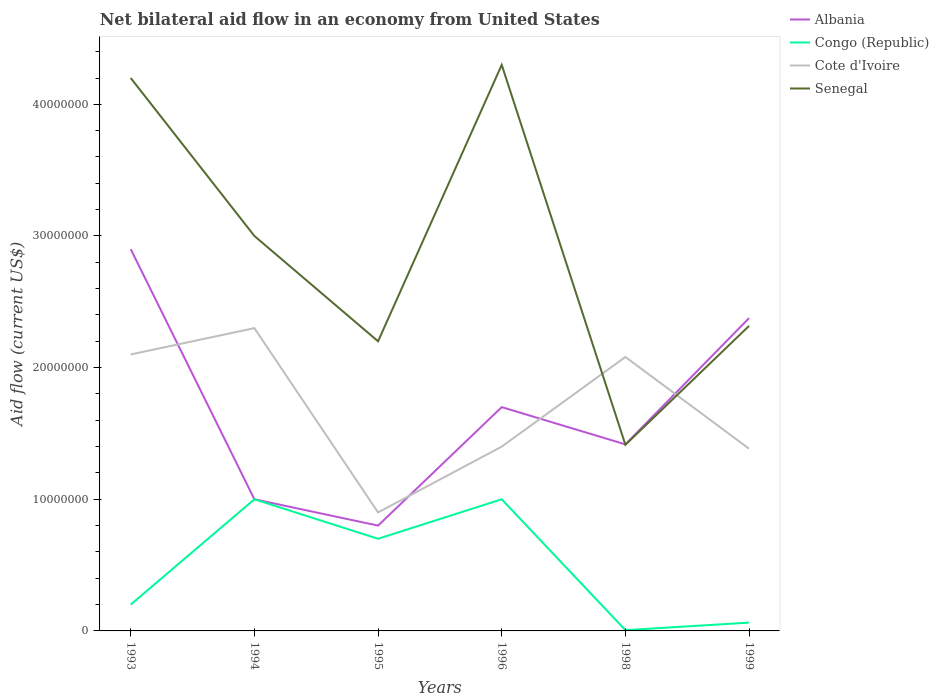How many different coloured lines are there?
Ensure brevity in your answer.  4. Does the line corresponding to Cote d'Ivoire intersect with the line corresponding to Senegal?
Keep it short and to the point. Yes. Is the number of lines equal to the number of legend labels?
Ensure brevity in your answer.  Yes. What is the total net bilateral aid flow in Cote d'Ivoire in the graph?
Offer a terse response. 1.90e+05. What is the difference between the highest and the second highest net bilateral aid flow in Congo (Republic)?
Your answer should be compact. 9.94e+06. What is the difference between the highest and the lowest net bilateral aid flow in Congo (Republic)?
Keep it short and to the point. 3. Is the net bilateral aid flow in Congo (Republic) strictly greater than the net bilateral aid flow in Cote d'Ivoire over the years?
Ensure brevity in your answer.  Yes. How many lines are there?
Your answer should be compact. 4. What is the difference between two consecutive major ticks on the Y-axis?
Offer a very short reply. 1.00e+07. How many legend labels are there?
Provide a short and direct response. 4. How are the legend labels stacked?
Offer a terse response. Vertical. What is the title of the graph?
Give a very brief answer. Net bilateral aid flow in an economy from United States. Does "Djibouti" appear as one of the legend labels in the graph?
Make the answer very short. No. What is the label or title of the Y-axis?
Give a very brief answer. Aid flow (current US$). What is the Aid flow (current US$) of Albania in 1993?
Provide a short and direct response. 2.90e+07. What is the Aid flow (current US$) of Cote d'Ivoire in 1993?
Ensure brevity in your answer.  2.10e+07. What is the Aid flow (current US$) of Senegal in 1993?
Give a very brief answer. 4.20e+07. What is the Aid flow (current US$) in Cote d'Ivoire in 1994?
Offer a terse response. 2.30e+07. What is the Aid flow (current US$) in Senegal in 1994?
Make the answer very short. 3.00e+07. What is the Aid flow (current US$) of Congo (Republic) in 1995?
Offer a very short reply. 7.00e+06. What is the Aid flow (current US$) of Cote d'Ivoire in 1995?
Keep it short and to the point. 9.00e+06. What is the Aid flow (current US$) in Senegal in 1995?
Offer a terse response. 2.20e+07. What is the Aid flow (current US$) of Albania in 1996?
Your response must be concise. 1.70e+07. What is the Aid flow (current US$) in Cote d'Ivoire in 1996?
Provide a succinct answer. 1.40e+07. What is the Aid flow (current US$) in Senegal in 1996?
Ensure brevity in your answer.  4.30e+07. What is the Aid flow (current US$) in Albania in 1998?
Your answer should be very brief. 1.42e+07. What is the Aid flow (current US$) in Cote d'Ivoire in 1998?
Your answer should be very brief. 2.08e+07. What is the Aid flow (current US$) of Senegal in 1998?
Give a very brief answer. 1.41e+07. What is the Aid flow (current US$) in Albania in 1999?
Give a very brief answer. 2.38e+07. What is the Aid flow (current US$) of Congo (Republic) in 1999?
Your answer should be compact. 6.30e+05. What is the Aid flow (current US$) of Cote d'Ivoire in 1999?
Offer a very short reply. 1.38e+07. What is the Aid flow (current US$) of Senegal in 1999?
Your response must be concise. 2.32e+07. Across all years, what is the maximum Aid flow (current US$) of Albania?
Provide a short and direct response. 2.90e+07. Across all years, what is the maximum Aid flow (current US$) of Cote d'Ivoire?
Your response must be concise. 2.30e+07. Across all years, what is the maximum Aid flow (current US$) of Senegal?
Give a very brief answer. 4.30e+07. Across all years, what is the minimum Aid flow (current US$) in Cote d'Ivoire?
Make the answer very short. 9.00e+06. Across all years, what is the minimum Aid flow (current US$) in Senegal?
Your answer should be compact. 1.41e+07. What is the total Aid flow (current US$) of Albania in the graph?
Your response must be concise. 1.02e+08. What is the total Aid flow (current US$) in Congo (Republic) in the graph?
Ensure brevity in your answer.  2.97e+07. What is the total Aid flow (current US$) of Cote d'Ivoire in the graph?
Ensure brevity in your answer.  1.02e+08. What is the total Aid flow (current US$) in Senegal in the graph?
Ensure brevity in your answer.  1.74e+08. What is the difference between the Aid flow (current US$) of Albania in 1993 and that in 1994?
Provide a succinct answer. 1.90e+07. What is the difference between the Aid flow (current US$) in Congo (Republic) in 1993 and that in 1994?
Give a very brief answer. -8.00e+06. What is the difference between the Aid flow (current US$) of Senegal in 1993 and that in 1994?
Offer a very short reply. 1.20e+07. What is the difference between the Aid flow (current US$) of Albania in 1993 and that in 1995?
Your response must be concise. 2.10e+07. What is the difference between the Aid flow (current US$) of Congo (Republic) in 1993 and that in 1995?
Make the answer very short. -5.00e+06. What is the difference between the Aid flow (current US$) in Senegal in 1993 and that in 1995?
Offer a very short reply. 2.00e+07. What is the difference between the Aid flow (current US$) in Congo (Republic) in 1993 and that in 1996?
Ensure brevity in your answer.  -8.00e+06. What is the difference between the Aid flow (current US$) of Albania in 1993 and that in 1998?
Make the answer very short. 1.48e+07. What is the difference between the Aid flow (current US$) in Congo (Republic) in 1993 and that in 1998?
Give a very brief answer. 1.94e+06. What is the difference between the Aid flow (current US$) in Senegal in 1993 and that in 1998?
Your answer should be compact. 2.79e+07. What is the difference between the Aid flow (current US$) of Albania in 1993 and that in 1999?
Provide a succinct answer. 5.24e+06. What is the difference between the Aid flow (current US$) in Congo (Republic) in 1993 and that in 1999?
Provide a succinct answer. 1.37e+06. What is the difference between the Aid flow (current US$) of Cote d'Ivoire in 1993 and that in 1999?
Give a very brief answer. 7.16e+06. What is the difference between the Aid flow (current US$) of Senegal in 1993 and that in 1999?
Ensure brevity in your answer.  1.88e+07. What is the difference between the Aid flow (current US$) of Albania in 1994 and that in 1995?
Provide a short and direct response. 2.00e+06. What is the difference between the Aid flow (current US$) in Congo (Republic) in 1994 and that in 1995?
Give a very brief answer. 3.00e+06. What is the difference between the Aid flow (current US$) of Cote d'Ivoire in 1994 and that in 1995?
Make the answer very short. 1.40e+07. What is the difference between the Aid flow (current US$) in Albania in 1994 and that in 1996?
Keep it short and to the point. -7.00e+06. What is the difference between the Aid flow (current US$) of Congo (Republic) in 1994 and that in 1996?
Your answer should be compact. 0. What is the difference between the Aid flow (current US$) of Cote d'Ivoire in 1994 and that in 1996?
Offer a terse response. 9.00e+06. What is the difference between the Aid flow (current US$) of Senegal in 1994 and that in 1996?
Provide a short and direct response. -1.30e+07. What is the difference between the Aid flow (current US$) of Albania in 1994 and that in 1998?
Offer a very short reply. -4.17e+06. What is the difference between the Aid flow (current US$) of Congo (Republic) in 1994 and that in 1998?
Your answer should be very brief. 9.94e+06. What is the difference between the Aid flow (current US$) of Cote d'Ivoire in 1994 and that in 1998?
Your answer should be very brief. 2.19e+06. What is the difference between the Aid flow (current US$) in Senegal in 1994 and that in 1998?
Your answer should be very brief. 1.59e+07. What is the difference between the Aid flow (current US$) in Albania in 1994 and that in 1999?
Ensure brevity in your answer.  -1.38e+07. What is the difference between the Aid flow (current US$) in Congo (Republic) in 1994 and that in 1999?
Your answer should be compact. 9.37e+06. What is the difference between the Aid flow (current US$) of Cote d'Ivoire in 1994 and that in 1999?
Give a very brief answer. 9.16e+06. What is the difference between the Aid flow (current US$) in Senegal in 1994 and that in 1999?
Ensure brevity in your answer.  6.83e+06. What is the difference between the Aid flow (current US$) of Albania in 1995 and that in 1996?
Your answer should be compact. -9.00e+06. What is the difference between the Aid flow (current US$) of Cote d'Ivoire in 1995 and that in 1996?
Your answer should be very brief. -5.00e+06. What is the difference between the Aid flow (current US$) in Senegal in 1995 and that in 1996?
Keep it short and to the point. -2.10e+07. What is the difference between the Aid flow (current US$) in Albania in 1995 and that in 1998?
Provide a succinct answer. -6.17e+06. What is the difference between the Aid flow (current US$) in Congo (Republic) in 1995 and that in 1998?
Your answer should be compact. 6.94e+06. What is the difference between the Aid flow (current US$) of Cote d'Ivoire in 1995 and that in 1998?
Ensure brevity in your answer.  -1.18e+07. What is the difference between the Aid flow (current US$) in Senegal in 1995 and that in 1998?
Your response must be concise. 7.86e+06. What is the difference between the Aid flow (current US$) of Albania in 1995 and that in 1999?
Offer a terse response. -1.58e+07. What is the difference between the Aid flow (current US$) in Congo (Republic) in 1995 and that in 1999?
Your response must be concise. 6.37e+06. What is the difference between the Aid flow (current US$) of Cote d'Ivoire in 1995 and that in 1999?
Provide a succinct answer. -4.84e+06. What is the difference between the Aid flow (current US$) of Senegal in 1995 and that in 1999?
Offer a very short reply. -1.17e+06. What is the difference between the Aid flow (current US$) in Albania in 1996 and that in 1998?
Keep it short and to the point. 2.83e+06. What is the difference between the Aid flow (current US$) in Congo (Republic) in 1996 and that in 1998?
Offer a terse response. 9.94e+06. What is the difference between the Aid flow (current US$) in Cote d'Ivoire in 1996 and that in 1998?
Offer a terse response. -6.81e+06. What is the difference between the Aid flow (current US$) in Senegal in 1996 and that in 1998?
Make the answer very short. 2.89e+07. What is the difference between the Aid flow (current US$) of Albania in 1996 and that in 1999?
Ensure brevity in your answer.  -6.76e+06. What is the difference between the Aid flow (current US$) of Congo (Republic) in 1996 and that in 1999?
Make the answer very short. 9.37e+06. What is the difference between the Aid flow (current US$) of Senegal in 1996 and that in 1999?
Provide a succinct answer. 1.98e+07. What is the difference between the Aid flow (current US$) of Albania in 1998 and that in 1999?
Your answer should be compact. -9.59e+06. What is the difference between the Aid flow (current US$) in Congo (Republic) in 1998 and that in 1999?
Your answer should be very brief. -5.70e+05. What is the difference between the Aid flow (current US$) in Cote d'Ivoire in 1998 and that in 1999?
Give a very brief answer. 6.97e+06. What is the difference between the Aid flow (current US$) of Senegal in 1998 and that in 1999?
Your response must be concise. -9.03e+06. What is the difference between the Aid flow (current US$) in Albania in 1993 and the Aid flow (current US$) in Congo (Republic) in 1994?
Your response must be concise. 1.90e+07. What is the difference between the Aid flow (current US$) in Congo (Republic) in 1993 and the Aid flow (current US$) in Cote d'Ivoire in 1994?
Provide a succinct answer. -2.10e+07. What is the difference between the Aid flow (current US$) in Congo (Republic) in 1993 and the Aid flow (current US$) in Senegal in 1994?
Your answer should be very brief. -2.80e+07. What is the difference between the Aid flow (current US$) in Cote d'Ivoire in 1993 and the Aid flow (current US$) in Senegal in 1994?
Keep it short and to the point. -9.00e+06. What is the difference between the Aid flow (current US$) of Albania in 1993 and the Aid flow (current US$) of Congo (Republic) in 1995?
Provide a short and direct response. 2.20e+07. What is the difference between the Aid flow (current US$) in Albania in 1993 and the Aid flow (current US$) in Cote d'Ivoire in 1995?
Offer a terse response. 2.00e+07. What is the difference between the Aid flow (current US$) of Albania in 1993 and the Aid flow (current US$) of Senegal in 1995?
Give a very brief answer. 7.00e+06. What is the difference between the Aid flow (current US$) in Congo (Republic) in 1993 and the Aid flow (current US$) in Cote d'Ivoire in 1995?
Provide a short and direct response. -7.00e+06. What is the difference between the Aid flow (current US$) in Congo (Republic) in 1993 and the Aid flow (current US$) in Senegal in 1995?
Your response must be concise. -2.00e+07. What is the difference between the Aid flow (current US$) of Albania in 1993 and the Aid flow (current US$) of Congo (Republic) in 1996?
Offer a very short reply. 1.90e+07. What is the difference between the Aid flow (current US$) of Albania in 1993 and the Aid flow (current US$) of Cote d'Ivoire in 1996?
Keep it short and to the point. 1.50e+07. What is the difference between the Aid flow (current US$) of Albania in 1993 and the Aid flow (current US$) of Senegal in 1996?
Your answer should be compact. -1.40e+07. What is the difference between the Aid flow (current US$) of Congo (Republic) in 1993 and the Aid flow (current US$) of Cote d'Ivoire in 1996?
Give a very brief answer. -1.20e+07. What is the difference between the Aid flow (current US$) in Congo (Republic) in 1993 and the Aid flow (current US$) in Senegal in 1996?
Your answer should be compact. -4.10e+07. What is the difference between the Aid flow (current US$) of Cote d'Ivoire in 1993 and the Aid flow (current US$) of Senegal in 1996?
Ensure brevity in your answer.  -2.20e+07. What is the difference between the Aid flow (current US$) in Albania in 1993 and the Aid flow (current US$) in Congo (Republic) in 1998?
Your response must be concise. 2.89e+07. What is the difference between the Aid flow (current US$) in Albania in 1993 and the Aid flow (current US$) in Cote d'Ivoire in 1998?
Provide a succinct answer. 8.19e+06. What is the difference between the Aid flow (current US$) in Albania in 1993 and the Aid flow (current US$) in Senegal in 1998?
Your answer should be compact. 1.49e+07. What is the difference between the Aid flow (current US$) in Congo (Republic) in 1993 and the Aid flow (current US$) in Cote d'Ivoire in 1998?
Make the answer very short. -1.88e+07. What is the difference between the Aid flow (current US$) of Congo (Republic) in 1993 and the Aid flow (current US$) of Senegal in 1998?
Keep it short and to the point. -1.21e+07. What is the difference between the Aid flow (current US$) in Cote d'Ivoire in 1993 and the Aid flow (current US$) in Senegal in 1998?
Provide a succinct answer. 6.86e+06. What is the difference between the Aid flow (current US$) of Albania in 1993 and the Aid flow (current US$) of Congo (Republic) in 1999?
Provide a short and direct response. 2.84e+07. What is the difference between the Aid flow (current US$) of Albania in 1993 and the Aid flow (current US$) of Cote d'Ivoire in 1999?
Make the answer very short. 1.52e+07. What is the difference between the Aid flow (current US$) in Albania in 1993 and the Aid flow (current US$) in Senegal in 1999?
Provide a succinct answer. 5.83e+06. What is the difference between the Aid flow (current US$) in Congo (Republic) in 1993 and the Aid flow (current US$) in Cote d'Ivoire in 1999?
Make the answer very short. -1.18e+07. What is the difference between the Aid flow (current US$) of Congo (Republic) in 1993 and the Aid flow (current US$) of Senegal in 1999?
Your answer should be compact. -2.12e+07. What is the difference between the Aid flow (current US$) in Cote d'Ivoire in 1993 and the Aid flow (current US$) in Senegal in 1999?
Provide a short and direct response. -2.17e+06. What is the difference between the Aid flow (current US$) of Albania in 1994 and the Aid flow (current US$) of Congo (Republic) in 1995?
Offer a very short reply. 3.00e+06. What is the difference between the Aid flow (current US$) of Albania in 1994 and the Aid flow (current US$) of Cote d'Ivoire in 1995?
Make the answer very short. 1.00e+06. What is the difference between the Aid flow (current US$) of Albania in 1994 and the Aid flow (current US$) of Senegal in 1995?
Your answer should be compact. -1.20e+07. What is the difference between the Aid flow (current US$) in Congo (Republic) in 1994 and the Aid flow (current US$) in Cote d'Ivoire in 1995?
Offer a terse response. 1.00e+06. What is the difference between the Aid flow (current US$) in Congo (Republic) in 1994 and the Aid flow (current US$) in Senegal in 1995?
Your answer should be very brief. -1.20e+07. What is the difference between the Aid flow (current US$) of Cote d'Ivoire in 1994 and the Aid flow (current US$) of Senegal in 1995?
Provide a short and direct response. 1.00e+06. What is the difference between the Aid flow (current US$) in Albania in 1994 and the Aid flow (current US$) in Senegal in 1996?
Offer a very short reply. -3.30e+07. What is the difference between the Aid flow (current US$) of Congo (Republic) in 1994 and the Aid flow (current US$) of Senegal in 1996?
Your answer should be compact. -3.30e+07. What is the difference between the Aid flow (current US$) of Cote d'Ivoire in 1994 and the Aid flow (current US$) of Senegal in 1996?
Your response must be concise. -2.00e+07. What is the difference between the Aid flow (current US$) in Albania in 1994 and the Aid flow (current US$) in Congo (Republic) in 1998?
Offer a terse response. 9.94e+06. What is the difference between the Aid flow (current US$) in Albania in 1994 and the Aid flow (current US$) in Cote d'Ivoire in 1998?
Offer a terse response. -1.08e+07. What is the difference between the Aid flow (current US$) of Albania in 1994 and the Aid flow (current US$) of Senegal in 1998?
Ensure brevity in your answer.  -4.14e+06. What is the difference between the Aid flow (current US$) in Congo (Republic) in 1994 and the Aid flow (current US$) in Cote d'Ivoire in 1998?
Make the answer very short. -1.08e+07. What is the difference between the Aid flow (current US$) in Congo (Republic) in 1994 and the Aid flow (current US$) in Senegal in 1998?
Make the answer very short. -4.14e+06. What is the difference between the Aid flow (current US$) of Cote d'Ivoire in 1994 and the Aid flow (current US$) of Senegal in 1998?
Offer a terse response. 8.86e+06. What is the difference between the Aid flow (current US$) in Albania in 1994 and the Aid flow (current US$) in Congo (Republic) in 1999?
Keep it short and to the point. 9.37e+06. What is the difference between the Aid flow (current US$) of Albania in 1994 and the Aid flow (current US$) of Cote d'Ivoire in 1999?
Your response must be concise. -3.84e+06. What is the difference between the Aid flow (current US$) in Albania in 1994 and the Aid flow (current US$) in Senegal in 1999?
Keep it short and to the point. -1.32e+07. What is the difference between the Aid flow (current US$) in Congo (Republic) in 1994 and the Aid flow (current US$) in Cote d'Ivoire in 1999?
Provide a short and direct response. -3.84e+06. What is the difference between the Aid flow (current US$) in Congo (Republic) in 1994 and the Aid flow (current US$) in Senegal in 1999?
Your answer should be compact. -1.32e+07. What is the difference between the Aid flow (current US$) in Cote d'Ivoire in 1994 and the Aid flow (current US$) in Senegal in 1999?
Offer a very short reply. -1.70e+05. What is the difference between the Aid flow (current US$) of Albania in 1995 and the Aid flow (current US$) of Cote d'Ivoire in 1996?
Keep it short and to the point. -6.00e+06. What is the difference between the Aid flow (current US$) of Albania in 1995 and the Aid flow (current US$) of Senegal in 1996?
Provide a short and direct response. -3.50e+07. What is the difference between the Aid flow (current US$) in Congo (Republic) in 1995 and the Aid flow (current US$) in Cote d'Ivoire in 1996?
Ensure brevity in your answer.  -7.00e+06. What is the difference between the Aid flow (current US$) of Congo (Republic) in 1995 and the Aid flow (current US$) of Senegal in 1996?
Your answer should be compact. -3.60e+07. What is the difference between the Aid flow (current US$) of Cote d'Ivoire in 1995 and the Aid flow (current US$) of Senegal in 1996?
Offer a very short reply. -3.40e+07. What is the difference between the Aid flow (current US$) in Albania in 1995 and the Aid flow (current US$) in Congo (Republic) in 1998?
Give a very brief answer. 7.94e+06. What is the difference between the Aid flow (current US$) in Albania in 1995 and the Aid flow (current US$) in Cote d'Ivoire in 1998?
Provide a succinct answer. -1.28e+07. What is the difference between the Aid flow (current US$) of Albania in 1995 and the Aid flow (current US$) of Senegal in 1998?
Your response must be concise. -6.14e+06. What is the difference between the Aid flow (current US$) of Congo (Republic) in 1995 and the Aid flow (current US$) of Cote d'Ivoire in 1998?
Ensure brevity in your answer.  -1.38e+07. What is the difference between the Aid flow (current US$) of Congo (Republic) in 1995 and the Aid flow (current US$) of Senegal in 1998?
Keep it short and to the point. -7.14e+06. What is the difference between the Aid flow (current US$) in Cote d'Ivoire in 1995 and the Aid flow (current US$) in Senegal in 1998?
Make the answer very short. -5.14e+06. What is the difference between the Aid flow (current US$) of Albania in 1995 and the Aid flow (current US$) of Congo (Republic) in 1999?
Provide a succinct answer. 7.37e+06. What is the difference between the Aid flow (current US$) of Albania in 1995 and the Aid flow (current US$) of Cote d'Ivoire in 1999?
Your response must be concise. -5.84e+06. What is the difference between the Aid flow (current US$) in Albania in 1995 and the Aid flow (current US$) in Senegal in 1999?
Give a very brief answer. -1.52e+07. What is the difference between the Aid flow (current US$) of Congo (Republic) in 1995 and the Aid flow (current US$) of Cote d'Ivoire in 1999?
Your answer should be very brief. -6.84e+06. What is the difference between the Aid flow (current US$) of Congo (Republic) in 1995 and the Aid flow (current US$) of Senegal in 1999?
Give a very brief answer. -1.62e+07. What is the difference between the Aid flow (current US$) in Cote d'Ivoire in 1995 and the Aid flow (current US$) in Senegal in 1999?
Keep it short and to the point. -1.42e+07. What is the difference between the Aid flow (current US$) of Albania in 1996 and the Aid flow (current US$) of Congo (Republic) in 1998?
Ensure brevity in your answer.  1.69e+07. What is the difference between the Aid flow (current US$) in Albania in 1996 and the Aid flow (current US$) in Cote d'Ivoire in 1998?
Give a very brief answer. -3.81e+06. What is the difference between the Aid flow (current US$) of Albania in 1996 and the Aid flow (current US$) of Senegal in 1998?
Your response must be concise. 2.86e+06. What is the difference between the Aid flow (current US$) in Congo (Republic) in 1996 and the Aid flow (current US$) in Cote d'Ivoire in 1998?
Give a very brief answer. -1.08e+07. What is the difference between the Aid flow (current US$) in Congo (Republic) in 1996 and the Aid flow (current US$) in Senegal in 1998?
Your answer should be very brief. -4.14e+06. What is the difference between the Aid flow (current US$) in Albania in 1996 and the Aid flow (current US$) in Congo (Republic) in 1999?
Ensure brevity in your answer.  1.64e+07. What is the difference between the Aid flow (current US$) in Albania in 1996 and the Aid flow (current US$) in Cote d'Ivoire in 1999?
Ensure brevity in your answer.  3.16e+06. What is the difference between the Aid flow (current US$) of Albania in 1996 and the Aid flow (current US$) of Senegal in 1999?
Provide a succinct answer. -6.17e+06. What is the difference between the Aid flow (current US$) of Congo (Republic) in 1996 and the Aid flow (current US$) of Cote d'Ivoire in 1999?
Your response must be concise. -3.84e+06. What is the difference between the Aid flow (current US$) of Congo (Republic) in 1996 and the Aid flow (current US$) of Senegal in 1999?
Give a very brief answer. -1.32e+07. What is the difference between the Aid flow (current US$) in Cote d'Ivoire in 1996 and the Aid flow (current US$) in Senegal in 1999?
Offer a terse response. -9.17e+06. What is the difference between the Aid flow (current US$) of Albania in 1998 and the Aid flow (current US$) of Congo (Republic) in 1999?
Offer a very short reply. 1.35e+07. What is the difference between the Aid flow (current US$) of Albania in 1998 and the Aid flow (current US$) of Cote d'Ivoire in 1999?
Provide a short and direct response. 3.30e+05. What is the difference between the Aid flow (current US$) of Albania in 1998 and the Aid flow (current US$) of Senegal in 1999?
Make the answer very short. -9.00e+06. What is the difference between the Aid flow (current US$) of Congo (Republic) in 1998 and the Aid flow (current US$) of Cote d'Ivoire in 1999?
Your answer should be very brief. -1.38e+07. What is the difference between the Aid flow (current US$) in Congo (Republic) in 1998 and the Aid flow (current US$) in Senegal in 1999?
Provide a succinct answer. -2.31e+07. What is the difference between the Aid flow (current US$) in Cote d'Ivoire in 1998 and the Aid flow (current US$) in Senegal in 1999?
Your answer should be compact. -2.36e+06. What is the average Aid flow (current US$) of Albania per year?
Your response must be concise. 1.70e+07. What is the average Aid flow (current US$) in Congo (Republic) per year?
Give a very brief answer. 4.95e+06. What is the average Aid flow (current US$) in Cote d'Ivoire per year?
Your response must be concise. 1.69e+07. What is the average Aid flow (current US$) of Senegal per year?
Provide a succinct answer. 2.91e+07. In the year 1993, what is the difference between the Aid flow (current US$) in Albania and Aid flow (current US$) in Congo (Republic)?
Ensure brevity in your answer.  2.70e+07. In the year 1993, what is the difference between the Aid flow (current US$) of Albania and Aid flow (current US$) of Cote d'Ivoire?
Ensure brevity in your answer.  8.00e+06. In the year 1993, what is the difference between the Aid flow (current US$) in Albania and Aid flow (current US$) in Senegal?
Your answer should be compact. -1.30e+07. In the year 1993, what is the difference between the Aid flow (current US$) of Congo (Republic) and Aid flow (current US$) of Cote d'Ivoire?
Provide a succinct answer. -1.90e+07. In the year 1993, what is the difference between the Aid flow (current US$) of Congo (Republic) and Aid flow (current US$) of Senegal?
Make the answer very short. -4.00e+07. In the year 1993, what is the difference between the Aid flow (current US$) of Cote d'Ivoire and Aid flow (current US$) of Senegal?
Provide a short and direct response. -2.10e+07. In the year 1994, what is the difference between the Aid flow (current US$) in Albania and Aid flow (current US$) in Cote d'Ivoire?
Keep it short and to the point. -1.30e+07. In the year 1994, what is the difference between the Aid flow (current US$) of Albania and Aid flow (current US$) of Senegal?
Offer a very short reply. -2.00e+07. In the year 1994, what is the difference between the Aid flow (current US$) in Congo (Republic) and Aid flow (current US$) in Cote d'Ivoire?
Keep it short and to the point. -1.30e+07. In the year 1994, what is the difference between the Aid flow (current US$) in Congo (Republic) and Aid flow (current US$) in Senegal?
Give a very brief answer. -2.00e+07. In the year 1994, what is the difference between the Aid flow (current US$) in Cote d'Ivoire and Aid flow (current US$) in Senegal?
Keep it short and to the point. -7.00e+06. In the year 1995, what is the difference between the Aid flow (current US$) in Albania and Aid flow (current US$) in Congo (Republic)?
Keep it short and to the point. 1.00e+06. In the year 1995, what is the difference between the Aid flow (current US$) of Albania and Aid flow (current US$) of Senegal?
Ensure brevity in your answer.  -1.40e+07. In the year 1995, what is the difference between the Aid flow (current US$) of Congo (Republic) and Aid flow (current US$) of Senegal?
Your answer should be compact. -1.50e+07. In the year 1995, what is the difference between the Aid flow (current US$) in Cote d'Ivoire and Aid flow (current US$) in Senegal?
Provide a short and direct response. -1.30e+07. In the year 1996, what is the difference between the Aid flow (current US$) of Albania and Aid flow (current US$) of Cote d'Ivoire?
Provide a short and direct response. 3.00e+06. In the year 1996, what is the difference between the Aid flow (current US$) of Albania and Aid flow (current US$) of Senegal?
Provide a short and direct response. -2.60e+07. In the year 1996, what is the difference between the Aid flow (current US$) in Congo (Republic) and Aid flow (current US$) in Cote d'Ivoire?
Give a very brief answer. -4.00e+06. In the year 1996, what is the difference between the Aid flow (current US$) of Congo (Republic) and Aid flow (current US$) of Senegal?
Give a very brief answer. -3.30e+07. In the year 1996, what is the difference between the Aid flow (current US$) of Cote d'Ivoire and Aid flow (current US$) of Senegal?
Make the answer very short. -2.90e+07. In the year 1998, what is the difference between the Aid flow (current US$) of Albania and Aid flow (current US$) of Congo (Republic)?
Give a very brief answer. 1.41e+07. In the year 1998, what is the difference between the Aid flow (current US$) of Albania and Aid flow (current US$) of Cote d'Ivoire?
Provide a short and direct response. -6.64e+06. In the year 1998, what is the difference between the Aid flow (current US$) in Albania and Aid flow (current US$) in Senegal?
Make the answer very short. 3.00e+04. In the year 1998, what is the difference between the Aid flow (current US$) of Congo (Republic) and Aid flow (current US$) of Cote d'Ivoire?
Provide a succinct answer. -2.08e+07. In the year 1998, what is the difference between the Aid flow (current US$) in Congo (Republic) and Aid flow (current US$) in Senegal?
Ensure brevity in your answer.  -1.41e+07. In the year 1998, what is the difference between the Aid flow (current US$) in Cote d'Ivoire and Aid flow (current US$) in Senegal?
Your answer should be compact. 6.67e+06. In the year 1999, what is the difference between the Aid flow (current US$) of Albania and Aid flow (current US$) of Congo (Republic)?
Offer a very short reply. 2.31e+07. In the year 1999, what is the difference between the Aid flow (current US$) of Albania and Aid flow (current US$) of Cote d'Ivoire?
Make the answer very short. 9.92e+06. In the year 1999, what is the difference between the Aid flow (current US$) in Albania and Aid flow (current US$) in Senegal?
Ensure brevity in your answer.  5.90e+05. In the year 1999, what is the difference between the Aid flow (current US$) in Congo (Republic) and Aid flow (current US$) in Cote d'Ivoire?
Provide a succinct answer. -1.32e+07. In the year 1999, what is the difference between the Aid flow (current US$) in Congo (Republic) and Aid flow (current US$) in Senegal?
Provide a short and direct response. -2.25e+07. In the year 1999, what is the difference between the Aid flow (current US$) in Cote d'Ivoire and Aid flow (current US$) in Senegal?
Offer a very short reply. -9.33e+06. What is the ratio of the Aid flow (current US$) of Senegal in 1993 to that in 1994?
Give a very brief answer. 1.4. What is the ratio of the Aid flow (current US$) of Albania in 1993 to that in 1995?
Make the answer very short. 3.62. What is the ratio of the Aid flow (current US$) of Congo (Republic) in 1993 to that in 1995?
Your answer should be very brief. 0.29. What is the ratio of the Aid flow (current US$) in Cote d'Ivoire in 1993 to that in 1995?
Your answer should be very brief. 2.33. What is the ratio of the Aid flow (current US$) of Senegal in 1993 to that in 1995?
Your answer should be very brief. 1.91. What is the ratio of the Aid flow (current US$) of Albania in 1993 to that in 1996?
Your answer should be compact. 1.71. What is the ratio of the Aid flow (current US$) in Congo (Republic) in 1993 to that in 1996?
Your response must be concise. 0.2. What is the ratio of the Aid flow (current US$) of Senegal in 1993 to that in 1996?
Offer a terse response. 0.98. What is the ratio of the Aid flow (current US$) in Albania in 1993 to that in 1998?
Offer a terse response. 2.05. What is the ratio of the Aid flow (current US$) of Congo (Republic) in 1993 to that in 1998?
Offer a terse response. 33.33. What is the ratio of the Aid flow (current US$) in Cote d'Ivoire in 1993 to that in 1998?
Make the answer very short. 1.01. What is the ratio of the Aid flow (current US$) in Senegal in 1993 to that in 1998?
Ensure brevity in your answer.  2.97. What is the ratio of the Aid flow (current US$) of Albania in 1993 to that in 1999?
Offer a very short reply. 1.22. What is the ratio of the Aid flow (current US$) in Congo (Republic) in 1993 to that in 1999?
Your response must be concise. 3.17. What is the ratio of the Aid flow (current US$) in Cote d'Ivoire in 1993 to that in 1999?
Ensure brevity in your answer.  1.52. What is the ratio of the Aid flow (current US$) of Senegal in 1993 to that in 1999?
Your answer should be very brief. 1.81. What is the ratio of the Aid flow (current US$) of Congo (Republic) in 1994 to that in 1995?
Provide a succinct answer. 1.43. What is the ratio of the Aid flow (current US$) of Cote d'Ivoire in 1994 to that in 1995?
Give a very brief answer. 2.56. What is the ratio of the Aid flow (current US$) of Senegal in 1994 to that in 1995?
Give a very brief answer. 1.36. What is the ratio of the Aid flow (current US$) in Albania in 1994 to that in 1996?
Ensure brevity in your answer.  0.59. What is the ratio of the Aid flow (current US$) of Cote d'Ivoire in 1994 to that in 1996?
Provide a short and direct response. 1.64. What is the ratio of the Aid flow (current US$) in Senegal in 1994 to that in 1996?
Offer a very short reply. 0.7. What is the ratio of the Aid flow (current US$) in Albania in 1994 to that in 1998?
Ensure brevity in your answer.  0.71. What is the ratio of the Aid flow (current US$) in Congo (Republic) in 1994 to that in 1998?
Keep it short and to the point. 166.67. What is the ratio of the Aid flow (current US$) in Cote d'Ivoire in 1994 to that in 1998?
Your answer should be compact. 1.11. What is the ratio of the Aid flow (current US$) of Senegal in 1994 to that in 1998?
Ensure brevity in your answer.  2.12. What is the ratio of the Aid flow (current US$) of Albania in 1994 to that in 1999?
Provide a short and direct response. 0.42. What is the ratio of the Aid flow (current US$) of Congo (Republic) in 1994 to that in 1999?
Your response must be concise. 15.87. What is the ratio of the Aid flow (current US$) in Cote d'Ivoire in 1994 to that in 1999?
Offer a terse response. 1.66. What is the ratio of the Aid flow (current US$) of Senegal in 1994 to that in 1999?
Your answer should be very brief. 1.29. What is the ratio of the Aid flow (current US$) of Albania in 1995 to that in 1996?
Provide a short and direct response. 0.47. What is the ratio of the Aid flow (current US$) of Congo (Republic) in 1995 to that in 1996?
Offer a very short reply. 0.7. What is the ratio of the Aid flow (current US$) of Cote d'Ivoire in 1995 to that in 1996?
Your answer should be compact. 0.64. What is the ratio of the Aid flow (current US$) in Senegal in 1995 to that in 1996?
Make the answer very short. 0.51. What is the ratio of the Aid flow (current US$) in Albania in 1995 to that in 1998?
Your response must be concise. 0.56. What is the ratio of the Aid flow (current US$) in Congo (Republic) in 1995 to that in 1998?
Give a very brief answer. 116.67. What is the ratio of the Aid flow (current US$) of Cote d'Ivoire in 1995 to that in 1998?
Your response must be concise. 0.43. What is the ratio of the Aid flow (current US$) of Senegal in 1995 to that in 1998?
Provide a short and direct response. 1.56. What is the ratio of the Aid flow (current US$) of Albania in 1995 to that in 1999?
Keep it short and to the point. 0.34. What is the ratio of the Aid flow (current US$) of Congo (Republic) in 1995 to that in 1999?
Your response must be concise. 11.11. What is the ratio of the Aid flow (current US$) in Cote d'Ivoire in 1995 to that in 1999?
Offer a terse response. 0.65. What is the ratio of the Aid flow (current US$) of Senegal in 1995 to that in 1999?
Provide a short and direct response. 0.95. What is the ratio of the Aid flow (current US$) in Albania in 1996 to that in 1998?
Your answer should be compact. 1.2. What is the ratio of the Aid flow (current US$) of Congo (Republic) in 1996 to that in 1998?
Your answer should be compact. 166.67. What is the ratio of the Aid flow (current US$) of Cote d'Ivoire in 1996 to that in 1998?
Provide a succinct answer. 0.67. What is the ratio of the Aid flow (current US$) in Senegal in 1996 to that in 1998?
Your answer should be very brief. 3.04. What is the ratio of the Aid flow (current US$) in Albania in 1996 to that in 1999?
Make the answer very short. 0.72. What is the ratio of the Aid flow (current US$) of Congo (Republic) in 1996 to that in 1999?
Your response must be concise. 15.87. What is the ratio of the Aid flow (current US$) in Cote d'Ivoire in 1996 to that in 1999?
Your response must be concise. 1.01. What is the ratio of the Aid flow (current US$) in Senegal in 1996 to that in 1999?
Make the answer very short. 1.86. What is the ratio of the Aid flow (current US$) of Albania in 1998 to that in 1999?
Provide a short and direct response. 0.6. What is the ratio of the Aid flow (current US$) of Congo (Republic) in 1998 to that in 1999?
Provide a succinct answer. 0.1. What is the ratio of the Aid flow (current US$) in Cote d'Ivoire in 1998 to that in 1999?
Your answer should be compact. 1.5. What is the ratio of the Aid flow (current US$) in Senegal in 1998 to that in 1999?
Your response must be concise. 0.61. What is the difference between the highest and the second highest Aid flow (current US$) of Albania?
Your answer should be very brief. 5.24e+06. What is the difference between the highest and the second highest Aid flow (current US$) in Congo (Republic)?
Offer a terse response. 0. What is the difference between the highest and the second highest Aid flow (current US$) of Cote d'Ivoire?
Your answer should be compact. 2.00e+06. What is the difference between the highest and the lowest Aid flow (current US$) in Albania?
Your answer should be very brief. 2.10e+07. What is the difference between the highest and the lowest Aid flow (current US$) of Congo (Republic)?
Your answer should be very brief. 9.94e+06. What is the difference between the highest and the lowest Aid flow (current US$) of Cote d'Ivoire?
Offer a very short reply. 1.40e+07. What is the difference between the highest and the lowest Aid flow (current US$) of Senegal?
Give a very brief answer. 2.89e+07. 